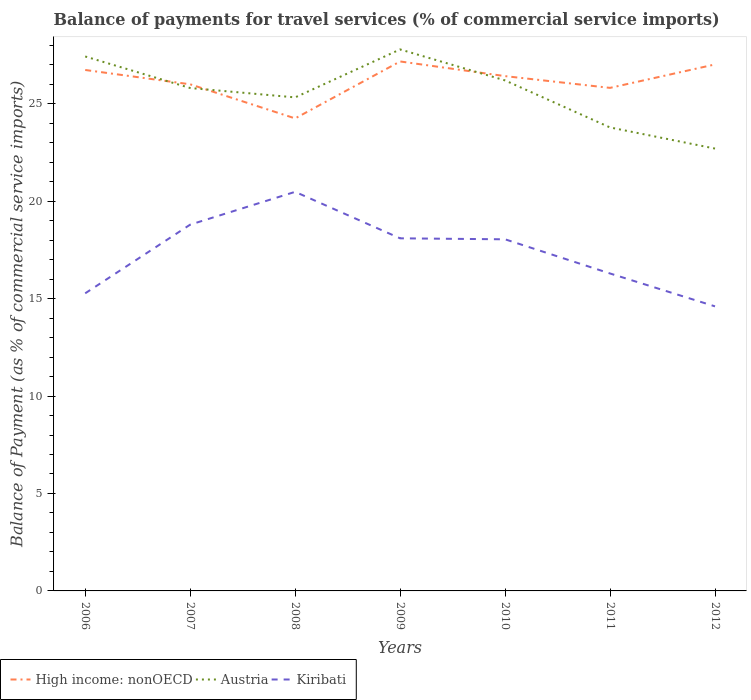Does the line corresponding to High income: nonOECD intersect with the line corresponding to Austria?
Offer a very short reply. Yes. Across all years, what is the maximum balance of payments for travel services in Kiribati?
Offer a terse response. 14.6. In which year was the balance of payments for travel services in Kiribati maximum?
Keep it short and to the point. 2012. What is the total balance of payments for travel services in High income: nonOECD in the graph?
Give a very brief answer. 0.92. What is the difference between the highest and the second highest balance of payments for travel services in Austria?
Provide a succinct answer. 5.09. Is the balance of payments for travel services in Austria strictly greater than the balance of payments for travel services in High income: nonOECD over the years?
Make the answer very short. No. How many lines are there?
Your answer should be compact. 3. What is the difference between two consecutive major ticks on the Y-axis?
Offer a terse response. 5. Does the graph contain grids?
Provide a short and direct response. No. What is the title of the graph?
Offer a very short reply. Balance of payments for travel services (% of commercial service imports). Does "Mexico" appear as one of the legend labels in the graph?
Your answer should be compact. No. What is the label or title of the Y-axis?
Your answer should be compact. Balance of Payment (as % of commercial service imports). What is the Balance of Payment (as % of commercial service imports) of High income: nonOECD in 2006?
Your response must be concise. 26.73. What is the Balance of Payment (as % of commercial service imports) of Austria in 2006?
Ensure brevity in your answer.  27.42. What is the Balance of Payment (as % of commercial service imports) of Kiribati in 2006?
Make the answer very short. 15.27. What is the Balance of Payment (as % of commercial service imports) of High income: nonOECD in 2007?
Keep it short and to the point. 25.99. What is the Balance of Payment (as % of commercial service imports) of Austria in 2007?
Keep it short and to the point. 25.8. What is the Balance of Payment (as % of commercial service imports) of Kiribati in 2007?
Make the answer very short. 18.79. What is the Balance of Payment (as % of commercial service imports) of High income: nonOECD in 2008?
Your response must be concise. 24.24. What is the Balance of Payment (as % of commercial service imports) in Austria in 2008?
Provide a succinct answer. 25.32. What is the Balance of Payment (as % of commercial service imports) of Kiribati in 2008?
Your answer should be compact. 20.48. What is the Balance of Payment (as % of commercial service imports) in High income: nonOECD in 2009?
Your answer should be compact. 27.17. What is the Balance of Payment (as % of commercial service imports) of Austria in 2009?
Offer a terse response. 27.78. What is the Balance of Payment (as % of commercial service imports) of Kiribati in 2009?
Give a very brief answer. 18.09. What is the Balance of Payment (as % of commercial service imports) of High income: nonOECD in 2010?
Offer a very short reply. 26.41. What is the Balance of Payment (as % of commercial service imports) in Austria in 2010?
Your answer should be very brief. 26.19. What is the Balance of Payment (as % of commercial service imports) of Kiribati in 2010?
Give a very brief answer. 18.04. What is the Balance of Payment (as % of commercial service imports) in High income: nonOECD in 2011?
Your answer should be very brief. 25.81. What is the Balance of Payment (as % of commercial service imports) in Austria in 2011?
Give a very brief answer. 23.78. What is the Balance of Payment (as % of commercial service imports) of Kiribati in 2011?
Make the answer very short. 16.29. What is the Balance of Payment (as % of commercial service imports) of High income: nonOECD in 2012?
Keep it short and to the point. 27.01. What is the Balance of Payment (as % of commercial service imports) of Austria in 2012?
Provide a succinct answer. 22.7. What is the Balance of Payment (as % of commercial service imports) in Kiribati in 2012?
Offer a terse response. 14.6. Across all years, what is the maximum Balance of Payment (as % of commercial service imports) of High income: nonOECD?
Provide a succinct answer. 27.17. Across all years, what is the maximum Balance of Payment (as % of commercial service imports) in Austria?
Keep it short and to the point. 27.78. Across all years, what is the maximum Balance of Payment (as % of commercial service imports) in Kiribati?
Offer a terse response. 20.48. Across all years, what is the minimum Balance of Payment (as % of commercial service imports) in High income: nonOECD?
Provide a succinct answer. 24.24. Across all years, what is the minimum Balance of Payment (as % of commercial service imports) of Austria?
Provide a short and direct response. 22.7. Across all years, what is the minimum Balance of Payment (as % of commercial service imports) of Kiribati?
Your response must be concise. 14.6. What is the total Balance of Payment (as % of commercial service imports) in High income: nonOECD in the graph?
Your answer should be very brief. 183.37. What is the total Balance of Payment (as % of commercial service imports) in Austria in the graph?
Offer a terse response. 179. What is the total Balance of Payment (as % of commercial service imports) of Kiribati in the graph?
Keep it short and to the point. 121.56. What is the difference between the Balance of Payment (as % of commercial service imports) in High income: nonOECD in 2006 and that in 2007?
Make the answer very short. 0.74. What is the difference between the Balance of Payment (as % of commercial service imports) in Austria in 2006 and that in 2007?
Provide a succinct answer. 1.62. What is the difference between the Balance of Payment (as % of commercial service imports) in Kiribati in 2006 and that in 2007?
Provide a succinct answer. -3.52. What is the difference between the Balance of Payment (as % of commercial service imports) of High income: nonOECD in 2006 and that in 2008?
Ensure brevity in your answer.  2.48. What is the difference between the Balance of Payment (as % of commercial service imports) of Austria in 2006 and that in 2008?
Give a very brief answer. 2.1. What is the difference between the Balance of Payment (as % of commercial service imports) in Kiribati in 2006 and that in 2008?
Make the answer very short. -5.21. What is the difference between the Balance of Payment (as % of commercial service imports) in High income: nonOECD in 2006 and that in 2009?
Make the answer very short. -0.44. What is the difference between the Balance of Payment (as % of commercial service imports) of Austria in 2006 and that in 2009?
Offer a terse response. -0.36. What is the difference between the Balance of Payment (as % of commercial service imports) of Kiribati in 2006 and that in 2009?
Your response must be concise. -2.82. What is the difference between the Balance of Payment (as % of commercial service imports) in High income: nonOECD in 2006 and that in 2010?
Ensure brevity in your answer.  0.32. What is the difference between the Balance of Payment (as % of commercial service imports) of Austria in 2006 and that in 2010?
Offer a terse response. 1.23. What is the difference between the Balance of Payment (as % of commercial service imports) of Kiribati in 2006 and that in 2010?
Make the answer very short. -2.77. What is the difference between the Balance of Payment (as % of commercial service imports) of High income: nonOECD in 2006 and that in 2011?
Ensure brevity in your answer.  0.92. What is the difference between the Balance of Payment (as % of commercial service imports) in Austria in 2006 and that in 2011?
Provide a succinct answer. 3.64. What is the difference between the Balance of Payment (as % of commercial service imports) in Kiribati in 2006 and that in 2011?
Ensure brevity in your answer.  -1.02. What is the difference between the Balance of Payment (as % of commercial service imports) of High income: nonOECD in 2006 and that in 2012?
Offer a terse response. -0.28. What is the difference between the Balance of Payment (as % of commercial service imports) in Austria in 2006 and that in 2012?
Keep it short and to the point. 4.73. What is the difference between the Balance of Payment (as % of commercial service imports) of Kiribati in 2006 and that in 2012?
Offer a terse response. 0.67. What is the difference between the Balance of Payment (as % of commercial service imports) in High income: nonOECD in 2007 and that in 2008?
Provide a short and direct response. 1.75. What is the difference between the Balance of Payment (as % of commercial service imports) in Austria in 2007 and that in 2008?
Ensure brevity in your answer.  0.48. What is the difference between the Balance of Payment (as % of commercial service imports) of Kiribati in 2007 and that in 2008?
Ensure brevity in your answer.  -1.68. What is the difference between the Balance of Payment (as % of commercial service imports) in High income: nonOECD in 2007 and that in 2009?
Ensure brevity in your answer.  -1.17. What is the difference between the Balance of Payment (as % of commercial service imports) of Austria in 2007 and that in 2009?
Your response must be concise. -1.98. What is the difference between the Balance of Payment (as % of commercial service imports) of Kiribati in 2007 and that in 2009?
Provide a short and direct response. 0.7. What is the difference between the Balance of Payment (as % of commercial service imports) of High income: nonOECD in 2007 and that in 2010?
Your answer should be very brief. -0.42. What is the difference between the Balance of Payment (as % of commercial service imports) of Austria in 2007 and that in 2010?
Offer a very short reply. -0.39. What is the difference between the Balance of Payment (as % of commercial service imports) of Kiribati in 2007 and that in 2010?
Your answer should be compact. 0.75. What is the difference between the Balance of Payment (as % of commercial service imports) of High income: nonOECD in 2007 and that in 2011?
Ensure brevity in your answer.  0.18. What is the difference between the Balance of Payment (as % of commercial service imports) in Austria in 2007 and that in 2011?
Your response must be concise. 2.02. What is the difference between the Balance of Payment (as % of commercial service imports) of Kiribati in 2007 and that in 2011?
Provide a short and direct response. 2.51. What is the difference between the Balance of Payment (as % of commercial service imports) of High income: nonOECD in 2007 and that in 2012?
Provide a short and direct response. -1.02. What is the difference between the Balance of Payment (as % of commercial service imports) in Austria in 2007 and that in 2012?
Make the answer very short. 3.11. What is the difference between the Balance of Payment (as % of commercial service imports) of Kiribati in 2007 and that in 2012?
Keep it short and to the point. 4.19. What is the difference between the Balance of Payment (as % of commercial service imports) in High income: nonOECD in 2008 and that in 2009?
Offer a terse response. -2.92. What is the difference between the Balance of Payment (as % of commercial service imports) in Austria in 2008 and that in 2009?
Provide a short and direct response. -2.46. What is the difference between the Balance of Payment (as % of commercial service imports) of Kiribati in 2008 and that in 2009?
Your answer should be very brief. 2.38. What is the difference between the Balance of Payment (as % of commercial service imports) in High income: nonOECD in 2008 and that in 2010?
Your answer should be compact. -2.17. What is the difference between the Balance of Payment (as % of commercial service imports) in Austria in 2008 and that in 2010?
Keep it short and to the point. -0.87. What is the difference between the Balance of Payment (as % of commercial service imports) of Kiribati in 2008 and that in 2010?
Your answer should be very brief. 2.44. What is the difference between the Balance of Payment (as % of commercial service imports) in High income: nonOECD in 2008 and that in 2011?
Your response must be concise. -1.57. What is the difference between the Balance of Payment (as % of commercial service imports) of Austria in 2008 and that in 2011?
Offer a very short reply. 1.54. What is the difference between the Balance of Payment (as % of commercial service imports) of Kiribati in 2008 and that in 2011?
Offer a very short reply. 4.19. What is the difference between the Balance of Payment (as % of commercial service imports) in High income: nonOECD in 2008 and that in 2012?
Your answer should be compact. -2.77. What is the difference between the Balance of Payment (as % of commercial service imports) of Austria in 2008 and that in 2012?
Your answer should be compact. 2.63. What is the difference between the Balance of Payment (as % of commercial service imports) of Kiribati in 2008 and that in 2012?
Offer a terse response. 5.88. What is the difference between the Balance of Payment (as % of commercial service imports) in High income: nonOECD in 2009 and that in 2010?
Your response must be concise. 0.75. What is the difference between the Balance of Payment (as % of commercial service imports) of Austria in 2009 and that in 2010?
Your answer should be compact. 1.59. What is the difference between the Balance of Payment (as % of commercial service imports) in Kiribati in 2009 and that in 2010?
Ensure brevity in your answer.  0.05. What is the difference between the Balance of Payment (as % of commercial service imports) in High income: nonOECD in 2009 and that in 2011?
Your answer should be compact. 1.36. What is the difference between the Balance of Payment (as % of commercial service imports) of Austria in 2009 and that in 2011?
Keep it short and to the point. 4. What is the difference between the Balance of Payment (as % of commercial service imports) in Kiribati in 2009 and that in 2011?
Make the answer very short. 1.8. What is the difference between the Balance of Payment (as % of commercial service imports) in High income: nonOECD in 2009 and that in 2012?
Offer a terse response. 0.15. What is the difference between the Balance of Payment (as % of commercial service imports) in Austria in 2009 and that in 2012?
Provide a succinct answer. 5.09. What is the difference between the Balance of Payment (as % of commercial service imports) of Kiribati in 2009 and that in 2012?
Your answer should be very brief. 3.49. What is the difference between the Balance of Payment (as % of commercial service imports) of High income: nonOECD in 2010 and that in 2011?
Ensure brevity in your answer.  0.6. What is the difference between the Balance of Payment (as % of commercial service imports) in Austria in 2010 and that in 2011?
Offer a terse response. 2.41. What is the difference between the Balance of Payment (as % of commercial service imports) in Kiribati in 2010 and that in 2011?
Offer a terse response. 1.75. What is the difference between the Balance of Payment (as % of commercial service imports) of High income: nonOECD in 2010 and that in 2012?
Make the answer very short. -0.6. What is the difference between the Balance of Payment (as % of commercial service imports) in Austria in 2010 and that in 2012?
Give a very brief answer. 3.5. What is the difference between the Balance of Payment (as % of commercial service imports) in Kiribati in 2010 and that in 2012?
Ensure brevity in your answer.  3.44. What is the difference between the Balance of Payment (as % of commercial service imports) of High income: nonOECD in 2011 and that in 2012?
Keep it short and to the point. -1.2. What is the difference between the Balance of Payment (as % of commercial service imports) of Austria in 2011 and that in 2012?
Ensure brevity in your answer.  1.08. What is the difference between the Balance of Payment (as % of commercial service imports) in Kiribati in 2011 and that in 2012?
Keep it short and to the point. 1.69. What is the difference between the Balance of Payment (as % of commercial service imports) in High income: nonOECD in 2006 and the Balance of Payment (as % of commercial service imports) in Austria in 2007?
Your response must be concise. 0.93. What is the difference between the Balance of Payment (as % of commercial service imports) of High income: nonOECD in 2006 and the Balance of Payment (as % of commercial service imports) of Kiribati in 2007?
Make the answer very short. 7.94. What is the difference between the Balance of Payment (as % of commercial service imports) in Austria in 2006 and the Balance of Payment (as % of commercial service imports) in Kiribati in 2007?
Make the answer very short. 8.63. What is the difference between the Balance of Payment (as % of commercial service imports) in High income: nonOECD in 2006 and the Balance of Payment (as % of commercial service imports) in Austria in 2008?
Offer a terse response. 1.41. What is the difference between the Balance of Payment (as % of commercial service imports) of High income: nonOECD in 2006 and the Balance of Payment (as % of commercial service imports) of Kiribati in 2008?
Offer a terse response. 6.25. What is the difference between the Balance of Payment (as % of commercial service imports) of Austria in 2006 and the Balance of Payment (as % of commercial service imports) of Kiribati in 2008?
Ensure brevity in your answer.  6.95. What is the difference between the Balance of Payment (as % of commercial service imports) of High income: nonOECD in 2006 and the Balance of Payment (as % of commercial service imports) of Austria in 2009?
Provide a short and direct response. -1.05. What is the difference between the Balance of Payment (as % of commercial service imports) of High income: nonOECD in 2006 and the Balance of Payment (as % of commercial service imports) of Kiribati in 2009?
Your answer should be very brief. 8.64. What is the difference between the Balance of Payment (as % of commercial service imports) in Austria in 2006 and the Balance of Payment (as % of commercial service imports) in Kiribati in 2009?
Make the answer very short. 9.33. What is the difference between the Balance of Payment (as % of commercial service imports) in High income: nonOECD in 2006 and the Balance of Payment (as % of commercial service imports) in Austria in 2010?
Ensure brevity in your answer.  0.54. What is the difference between the Balance of Payment (as % of commercial service imports) in High income: nonOECD in 2006 and the Balance of Payment (as % of commercial service imports) in Kiribati in 2010?
Provide a succinct answer. 8.69. What is the difference between the Balance of Payment (as % of commercial service imports) in Austria in 2006 and the Balance of Payment (as % of commercial service imports) in Kiribati in 2010?
Offer a terse response. 9.38. What is the difference between the Balance of Payment (as % of commercial service imports) in High income: nonOECD in 2006 and the Balance of Payment (as % of commercial service imports) in Austria in 2011?
Make the answer very short. 2.95. What is the difference between the Balance of Payment (as % of commercial service imports) in High income: nonOECD in 2006 and the Balance of Payment (as % of commercial service imports) in Kiribati in 2011?
Provide a succinct answer. 10.44. What is the difference between the Balance of Payment (as % of commercial service imports) of Austria in 2006 and the Balance of Payment (as % of commercial service imports) of Kiribati in 2011?
Ensure brevity in your answer.  11.13. What is the difference between the Balance of Payment (as % of commercial service imports) in High income: nonOECD in 2006 and the Balance of Payment (as % of commercial service imports) in Austria in 2012?
Give a very brief answer. 4.03. What is the difference between the Balance of Payment (as % of commercial service imports) of High income: nonOECD in 2006 and the Balance of Payment (as % of commercial service imports) of Kiribati in 2012?
Offer a very short reply. 12.13. What is the difference between the Balance of Payment (as % of commercial service imports) of Austria in 2006 and the Balance of Payment (as % of commercial service imports) of Kiribati in 2012?
Ensure brevity in your answer.  12.82. What is the difference between the Balance of Payment (as % of commercial service imports) in High income: nonOECD in 2007 and the Balance of Payment (as % of commercial service imports) in Austria in 2008?
Offer a very short reply. 0.67. What is the difference between the Balance of Payment (as % of commercial service imports) of High income: nonOECD in 2007 and the Balance of Payment (as % of commercial service imports) of Kiribati in 2008?
Offer a very short reply. 5.52. What is the difference between the Balance of Payment (as % of commercial service imports) of Austria in 2007 and the Balance of Payment (as % of commercial service imports) of Kiribati in 2008?
Give a very brief answer. 5.33. What is the difference between the Balance of Payment (as % of commercial service imports) in High income: nonOECD in 2007 and the Balance of Payment (as % of commercial service imports) in Austria in 2009?
Your answer should be compact. -1.79. What is the difference between the Balance of Payment (as % of commercial service imports) in High income: nonOECD in 2007 and the Balance of Payment (as % of commercial service imports) in Kiribati in 2009?
Provide a short and direct response. 7.9. What is the difference between the Balance of Payment (as % of commercial service imports) in Austria in 2007 and the Balance of Payment (as % of commercial service imports) in Kiribati in 2009?
Provide a short and direct response. 7.71. What is the difference between the Balance of Payment (as % of commercial service imports) in High income: nonOECD in 2007 and the Balance of Payment (as % of commercial service imports) in Austria in 2010?
Make the answer very short. -0.2. What is the difference between the Balance of Payment (as % of commercial service imports) of High income: nonOECD in 2007 and the Balance of Payment (as % of commercial service imports) of Kiribati in 2010?
Keep it short and to the point. 7.95. What is the difference between the Balance of Payment (as % of commercial service imports) of Austria in 2007 and the Balance of Payment (as % of commercial service imports) of Kiribati in 2010?
Ensure brevity in your answer.  7.76. What is the difference between the Balance of Payment (as % of commercial service imports) of High income: nonOECD in 2007 and the Balance of Payment (as % of commercial service imports) of Austria in 2011?
Give a very brief answer. 2.21. What is the difference between the Balance of Payment (as % of commercial service imports) in High income: nonOECD in 2007 and the Balance of Payment (as % of commercial service imports) in Kiribati in 2011?
Your response must be concise. 9.71. What is the difference between the Balance of Payment (as % of commercial service imports) in Austria in 2007 and the Balance of Payment (as % of commercial service imports) in Kiribati in 2011?
Ensure brevity in your answer.  9.52. What is the difference between the Balance of Payment (as % of commercial service imports) of High income: nonOECD in 2007 and the Balance of Payment (as % of commercial service imports) of Austria in 2012?
Offer a very short reply. 3.3. What is the difference between the Balance of Payment (as % of commercial service imports) of High income: nonOECD in 2007 and the Balance of Payment (as % of commercial service imports) of Kiribati in 2012?
Ensure brevity in your answer.  11.39. What is the difference between the Balance of Payment (as % of commercial service imports) in Austria in 2007 and the Balance of Payment (as % of commercial service imports) in Kiribati in 2012?
Provide a short and direct response. 11.2. What is the difference between the Balance of Payment (as % of commercial service imports) of High income: nonOECD in 2008 and the Balance of Payment (as % of commercial service imports) of Austria in 2009?
Your response must be concise. -3.54. What is the difference between the Balance of Payment (as % of commercial service imports) of High income: nonOECD in 2008 and the Balance of Payment (as % of commercial service imports) of Kiribati in 2009?
Your answer should be very brief. 6.15. What is the difference between the Balance of Payment (as % of commercial service imports) in Austria in 2008 and the Balance of Payment (as % of commercial service imports) in Kiribati in 2009?
Make the answer very short. 7.23. What is the difference between the Balance of Payment (as % of commercial service imports) in High income: nonOECD in 2008 and the Balance of Payment (as % of commercial service imports) in Austria in 2010?
Provide a succinct answer. -1.95. What is the difference between the Balance of Payment (as % of commercial service imports) of High income: nonOECD in 2008 and the Balance of Payment (as % of commercial service imports) of Kiribati in 2010?
Give a very brief answer. 6.2. What is the difference between the Balance of Payment (as % of commercial service imports) in Austria in 2008 and the Balance of Payment (as % of commercial service imports) in Kiribati in 2010?
Your answer should be compact. 7.28. What is the difference between the Balance of Payment (as % of commercial service imports) of High income: nonOECD in 2008 and the Balance of Payment (as % of commercial service imports) of Austria in 2011?
Your answer should be very brief. 0.46. What is the difference between the Balance of Payment (as % of commercial service imports) of High income: nonOECD in 2008 and the Balance of Payment (as % of commercial service imports) of Kiribati in 2011?
Your answer should be compact. 7.96. What is the difference between the Balance of Payment (as % of commercial service imports) in Austria in 2008 and the Balance of Payment (as % of commercial service imports) in Kiribati in 2011?
Ensure brevity in your answer.  9.04. What is the difference between the Balance of Payment (as % of commercial service imports) in High income: nonOECD in 2008 and the Balance of Payment (as % of commercial service imports) in Austria in 2012?
Offer a very short reply. 1.55. What is the difference between the Balance of Payment (as % of commercial service imports) in High income: nonOECD in 2008 and the Balance of Payment (as % of commercial service imports) in Kiribati in 2012?
Offer a terse response. 9.64. What is the difference between the Balance of Payment (as % of commercial service imports) of Austria in 2008 and the Balance of Payment (as % of commercial service imports) of Kiribati in 2012?
Your answer should be very brief. 10.72. What is the difference between the Balance of Payment (as % of commercial service imports) in High income: nonOECD in 2009 and the Balance of Payment (as % of commercial service imports) in Austria in 2010?
Give a very brief answer. 0.97. What is the difference between the Balance of Payment (as % of commercial service imports) in High income: nonOECD in 2009 and the Balance of Payment (as % of commercial service imports) in Kiribati in 2010?
Give a very brief answer. 9.13. What is the difference between the Balance of Payment (as % of commercial service imports) of Austria in 2009 and the Balance of Payment (as % of commercial service imports) of Kiribati in 2010?
Offer a terse response. 9.74. What is the difference between the Balance of Payment (as % of commercial service imports) in High income: nonOECD in 2009 and the Balance of Payment (as % of commercial service imports) in Austria in 2011?
Ensure brevity in your answer.  3.39. What is the difference between the Balance of Payment (as % of commercial service imports) in High income: nonOECD in 2009 and the Balance of Payment (as % of commercial service imports) in Kiribati in 2011?
Provide a short and direct response. 10.88. What is the difference between the Balance of Payment (as % of commercial service imports) in Austria in 2009 and the Balance of Payment (as % of commercial service imports) in Kiribati in 2011?
Provide a succinct answer. 11.5. What is the difference between the Balance of Payment (as % of commercial service imports) in High income: nonOECD in 2009 and the Balance of Payment (as % of commercial service imports) in Austria in 2012?
Make the answer very short. 4.47. What is the difference between the Balance of Payment (as % of commercial service imports) in High income: nonOECD in 2009 and the Balance of Payment (as % of commercial service imports) in Kiribati in 2012?
Offer a very short reply. 12.57. What is the difference between the Balance of Payment (as % of commercial service imports) of Austria in 2009 and the Balance of Payment (as % of commercial service imports) of Kiribati in 2012?
Your answer should be compact. 13.18. What is the difference between the Balance of Payment (as % of commercial service imports) in High income: nonOECD in 2010 and the Balance of Payment (as % of commercial service imports) in Austria in 2011?
Your answer should be compact. 2.63. What is the difference between the Balance of Payment (as % of commercial service imports) of High income: nonOECD in 2010 and the Balance of Payment (as % of commercial service imports) of Kiribati in 2011?
Your response must be concise. 10.13. What is the difference between the Balance of Payment (as % of commercial service imports) in Austria in 2010 and the Balance of Payment (as % of commercial service imports) in Kiribati in 2011?
Provide a succinct answer. 9.91. What is the difference between the Balance of Payment (as % of commercial service imports) of High income: nonOECD in 2010 and the Balance of Payment (as % of commercial service imports) of Austria in 2012?
Ensure brevity in your answer.  3.72. What is the difference between the Balance of Payment (as % of commercial service imports) of High income: nonOECD in 2010 and the Balance of Payment (as % of commercial service imports) of Kiribati in 2012?
Offer a very short reply. 11.81. What is the difference between the Balance of Payment (as % of commercial service imports) in Austria in 2010 and the Balance of Payment (as % of commercial service imports) in Kiribati in 2012?
Ensure brevity in your answer.  11.59. What is the difference between the Balance of Payment (as % of commercial service imports) in High income: nonOECD in 2011 and the Balance of Payment (as % of commercial service imports) in Austria in 2012?
Give a very brief answer. 3.11. What is the difference between the Balance of Payment (as % of commercial service imports) in High income: nonOECD in 2011 and the Balance of Payment (as % of commercial service imports) in Kiribati in 2012?
Offer a terse response. 11.21. What is the difference between the Balance of Payment (as % of commercial service imports) in Austria in 2011 and the Balance of Payment (as % of commercial service imports) in Kiribati in 2012?
Your answer should be very brief. 9.18. What is the average Balance of Payment (as % of commercial service imports) in High income: nonOECD per year?
Make the answer very short. 26.2. What is the average Balance of Payment (as % of commercial service imports) of Austria per year?
Offer a terse response. 25.57. What is the average Balance of Payment (as % of commercial service imports) in Kiribati per year?
Your response must be concise. 17.37. In the year 2006, what is the difference between the Balance of Payment (as % of commercial service imports) in High income: nonOECD and Balance of Payment (as % of commercial service imports) in Austria?
Give a very brief answer. -0.69. In the year 2006, what is the difference between the Balance of Payment (as % of commercial service imports) in High income: nonOECD and Balance of Payment (as % of commercial service imports) in Kiribati?
Give a very brief answer. 11.46. In the year 2006, what is the difference between the Balance of Payment (as % of commercial service imports) of Austria and Balance of Payment (as % of commercial service imports) of Kiribati?
Your answer should be very brief. 12.15. In the year 2007, what is the difference between the Balance of Payment (as % of commercial service imports) of High income: nonOECD and Balance of Payment (as % of commercial service imports) of Austria?
Provide a succinct answer. 0.19. In the year 2007, what is the difference between the Balance of Payment (as % of commercial service imports) of High income: nonOECD and Balance of Payment (as % of commercial service imports) of Kiribati?
Give a very brief answer. 7.2. In the year 2007, what is the difference between the Balance of Payment (as % of commercial service imports) in Austria and Balance of Payment (as % of commercial service imports) in Kiribati?
Ensure brevity in your answer.  7.01. In the year 2008, what is the difference between the Balance of Payment (as % of commercial service imports) in High income: nonOECD and Balance of Payment (as % of commercial service imports) in Austria?
Your answer should be very brief. -1.08. In the year 2008, what is the difference between the Balance of Payment (as % of commercial service imports) of High income: nonOECD and Balance of Payment (as % of commercial service imports) of Kiribati?
Offer a terse response. 3.77. In the year 2008, what is the difference between the Balance of Payment (as % of commercial service imports) of Austria and Balance of Payment (as % of commercial service imports) of Kiribati?
Offer a very short reply. 4.85. In the year 2009, what is the difference between the Balance of Payment (as % of commercial service imports) of High income: nonOECD and Balance of Payment (as % of commercial service imports) of Austria?
Provide a short and direct response. -0.62. In the year 2009, what is the difference between the Balance of Payment (as % of commercial service imports) of High income: nonOECD and Balance of Payment (as % of commercial service imports) of Kiribati?
Offer a terse response. 9.07. In the year 2009, what is the difference between the Balance of Payment (as % of commercial service imports) of Austria and Balance of Payment (as % of commercial service imports) of Kiribati?
Your answer should be very brief. 9.69. In the year 2010, what is the difference between the Balance of Payment (as % of commercial service imports) in High income: nonOECD and Balance of Payment (as % of commercial service imports) in Austria?
Make the answer very short. 0.22. In the year 2010, what is the difference between the Balance of Payment (as % of commercial service imports) in High income: nonOECD and Balance of Payment (as % of commercial service imports) in Kiribati?
Offer a very short reply. 8.37. In the year 2010, what is the difference between the Balance of Payment (as % of commercial service imports) in Austria and Balance of Payment (as % of commercial service imports) in Kiribati?
Keep it short and to the point. 8.15. In the year 2011, what is the difference between the Balance of Payment (as % of commercial service imports) in High income: nonOECD and Balance of Payment (as % of commercial service imports) in Austria?
Your response must be concise. 2.03. In the year 2011, what is the difference between the Balance of Payment (as % of commercial service imports) in High income: nonOECD and Balance of Payment (as % of commercial service imports) in Kiribati?
Give a very brief answer. 9.52. In the year 2011, what is the difference between the Balance of Payment (as % of commercial service imports) of Austria and Balance of Payment (as % of commercial service imports) of Kiribati?
Your response must be concise. 7.49. In the year 2012, what is the difference between the Balance of Payment (as % of commercial service imports) of High income: nonOECD and Balance of Payment (as % of commercial service imports) of Austria?
Offer a very short reply. 4.32. In the year 2012, what is the difference between the Balance of Payment (as % of commercial service imports) in High income: nonOECD and Balance of Payment (as % of commercial service imports) in Kiribati?
Provide a succinct answer. 12.41. In the year 2012, what is the difference between the Balance of Payment (as % of commercial service imports) of Austria and Balance of Payment (as % of commercial service imports) of Kiribati?
Provide a short and direct response. 8.1. What is the ratio of the Balance of Payment (as % of commercial service imports) of High income: nonOECD in 2006 to that in 2007?
Give a very brief answer. 1.03. What is the ratio of the Balance of Payment (as % of commercial service imports) in Austria in 2006 to that in 2007?
Give a very brief answer. 1.06. What is the ratio of the Balance of Payment (as % of commercial service imports) in Kiribati in 2006 to that in 2007?
Your answer should be compact. 0.81. What is the ratio of the Balance of Payment (as % of commercial service imports) in High income: nonOECD in 2006 to that in 2008?
Your response must be concise. 1.1. What is the ratio of the Balance of Payment (as % of commercial service imports) of Austria in 2006 to that in 2008?
Give a very brief answer. 1.08. What is the ratio of the Balance of Payment (as % of commercial service imports) in Kiribati in 2006 to that in 2008?
Offer a very short reply. 0.75. What is the ratio of the Balance of Payment (as % of commercial service imports) of High income: nonOECD in 2006 to that in 2009?
Offer a very short reply. 0.98. What is the ratio of the Balance of Payment (as % of commercial service imports) of Kiribati in 2006 to that in 2009?
Ensure brevity in your answer.  0.84. What is the ratio of the Balance of Payment (as % of commercial service imports) in High income: nonOECD in 2006 to that in 2010?
Give a very brief answer. 1.01. What is the ratio of the Balance of Payment (as % of commercial service imports) in Austria in 2006 to that in 2010?
Provide a short and direct response. 1.05. What is the ratio of the Balance of Payment (as % of commercial service imports) of Kiribati in 2006 to that in 2010?
Your response must be concise. 0.85. What is the ratio of the Balance of Payment (as % of commercial service imports) of High income: nonOECD in 2006 to that in 2011?
Make the answer very short. 1.04. What is the ratio of the Balance of Payment (as % of commercial service imports) of Austria in 2006 to that in 2011?
Your answer should be very brief. 1.15. What is the ratio of the Balance of Payment (as % of commercial service imports) in Kiribati in 2006 to that in 2011?
Make the answer very short. 0.94. What is the ratio of the Balance of Payment (as % of commercial service imports) in Austria in 2006 to that in 2012?
Your answer should be compact. 1.21. What is the ratio of the Balance of Payment (as % of commercial service imports) in Kiribati in 2006 to that in 2012?
Offer a very short reply. 1.05. What is the ratio of the Balance of Payment (as % of commercial service imports) in High income: nonOECD in 2007 to that in 2008?
Keep it short and to the point. 1.07. What is the ratio of the Balance of Payment (as % of commercial service imports) of Austria in 2007 to that in 2008?
Make the answer very short. 1.02. What is the ratio of the Balance of Payment (as % of commercial service imports) of Kiribati in 2007 to that in 2008?
Provide a succinct answer. 0.92. What is the ratio of the Balance of Payment (as % of commercial service imports) of High income: nonOECD in 2007 to that in 2009?
Make the answer very short. 0.96. What is the ratio of the Balance of Payment (as % of commercial service imports) of Austria in 2007 to that in 2009?
Ensure brevity in your answer.  0.93. What is the ratio of the Balance of Payment (as % of commercial service imports) in Kiribati in 2007 to that in 2009?
Make the answer very short. 1.04. What is the ratio of the Balance of Payment (as % of commercial service imports) in High income: nonOECD in 2007 to that in 2010?
Offer a terse response. 0.98. What is the ratio of the Balance of Payment (as % of commercial service imports) of Austria in 2007 to that in 2010?
Your answer should be very brief. 0.99. What is the ratio of the Balance of Payment (as % of commercial service imports) of Kiribati in 2007 to that in 2010?
Provide a succinct answer. 1.04. What is the ratio of the Balance of Payment (as % of commercial service imports) of High income: nonOECD in 2007 to that in 2011?
Keep it short and to the point. 1.01. What is the ratio of the Balance of Payment (as % of commercial service imports) of Austria in 2007 to that in 2011?
Ensure brevity in your answer.  1.09. What is the ratio of the Balance of Payment (as % of commercial service imports) in Kiribati in 2007 to that in 2011?
Make the answer very short. 1.15. What is the ratio of the Balance of Payment (as % of commercial service imports) in High income: nonOECD in 2007 to that in 2012?
Offer a terse response. 0.96. What is the ratio of the Balance of Payment (as % of commercial service imports) of Austria in 2007 to that in 2012?
Your answer should be compact. 1.14. What is the ratio of the Balance of Payment (as % of commercial service imports) of Kiribati in 2007 to that in 2012?
Offer a very short reply. 1.29. What is the ratio of the Balance of Payment (as % of commercial service imports) of High income: nonOECD in 2008 to that in 2009?
Your response must be concise. 0.89. What is the ratio of the Balance of Payment (as % of commercial service imports) in Austria in 2008 to that in 2009?
Provide a short and direct response. 0.91. What is the ratio of the Balance of Payment (as % of commercial service imports) in Kiribati in 2008 to that in 2009?
Provide a short and direct response. 1.13. What is the ratio of the Balance of Payment (as % of commercial service imports) in High income: nonOECD in 2008 to that in 2010?
Ensure brevity in your answer.  0.92. What is the ratio of the Balance of Payment (as % of commercial service imports) in Austria in 2008 to that in 2010?
Keep it short and to the point. 0.97. What is the ratio of the Balance of Payment (as % of commercial service imports) in Kiribati in 2008 to that in 2010?
Keep it short and to the point. 1.14. What is the ratio of the Balance of Payment (as % of commercial service imports) of High income: nonOECD in 2008 to that in 2011?
Your answer should be very brief. 0.94. What is the ratio of the Balance of Payment (as % of commercial service imports) of Austria in 2008 to that in 2011?
Provide a succinct answer. 1.06. What is the ratio of the Balance of Payment (as % of commercial service imports) in Kiribati in 2008 to that in 2011?
Give a very brief answer. 1.26. What is the ratio of the Balance of Payment (as % of commercial service imports) of High income: nonOECD in 2008 to that in 2012?
Your answer should be compact. 0.9. What is the ratio of the Balance of Payment (as % of commercial service imports) in Austria in 2008 to that in 2012?
Ensure brevity in your answer.  1.12. What is the ratio of the Balance of Payment (as % of commercial service imports) in Kiribati in 2008 to that in 2012?
Provide a succinct answer. 1.4. What is the ratio of the Balance of Payment (as % of commercial service imports) of High income: nonOECD in 2009 to that in 2010?
Keep it short and to the point. 1.03. What is the ratio of the Balance of Payment (as % of commercial service imports) in Austria in 2009 to that in 2010?
Provide a short and direct response. 1.06. What is the ratio of the Balance of Payment (as % of commercial service imports) in Kiribati in 2009 to that in 2010?
Your response must be concise. 1. What is the ratio of the Balance of Payment (as % of commercial service imports) of High income: nonOECD in 2009 to that in 2011?
Make the answer very short. 1.05. What is the ratio of the Balance of Payment (as % of commercial service imports) of Austria in 2009 to that in 2011?
Make the answer very short. 1.17. What is the ratio of the Balance of Payment (as % of commercial service imports) in Kiribati in 2009 to that in 2011?
Offer a terse response. 1.11. What is the ratio of the Balance of Payment (as % of commercial service imports) in High income: nonOECD in 2009 to that in 2012?
Provide a succinct answer. 1.01. What is the ratio of the Balance of Payment (as % of commercial service imports) of Austria in 2009 to that in 2012?
Offer a very short reply. 1.22. What is the ratio of the Balance of Payment (as % of commercial service imports) of Kiribati in 2009 to that in 2012?
Keep it short and to the point. 1.24. What is the ratio of the Balance of Payment (as % of commercial service imports) of High income: nonOECD in 2010 to that in 2011?
Your response must be concise. 1.02. What is the ratio of the Balance of Payment (as % of commercial service imports) of Austria in 2010 to that in 2011?
Provide a short and direct response. 1.1. What is the ratio of the Balance of Payment (as % of commercial service imports) in Kiribati in 2010 to that in 2011?
Give a very brief answer. 1.11. What is the ratio of the Balance of Payment (as % of commercial service imports) in High income: nonOECD in 2010 to that in 2012?
Make the answer very short. 0.98. What is the ratio of the Balance of Payment (as % of commercial service imports) of Austria in 2010 to that in 2012?
Make the answer very short. 1.15. What is the ratio of the Balance of Payment (as % of commercial service imports) of Kiribati in 2010 to that in 2012?
Your answer should be compact. 1.24. What is the ratio of the Balance of Payment (as % of commercial service imports) of High income: nonOECD in 2011 to that in 2012?
Give a very brief answer. 0.96. What is the ratio of the Balance of Payment (as % of commercial service imports) in Austria in 2011 to that in 2012?
Give a very brief answer. 1.05. What is the ratio of the Balance of Payment (as % of commercial service imports) in Kiribati in 2011 to that in 2012?
Provide a succinct answer. 1.12. What is the difference between the highest and the second highest Balance of Payment (as % of commercial service imports) in High income: nonOECD?
Offer a very short reply. 0.15. What is the difference between the highest and the second highest Balance of Payment (as % of commercial service imports) of Austria?
Offer a very short reply. 0.36. What is the difference between the highest and the second highest Balance of Payment (as % of commercial service imports) of Kiribati?
Your answer should be compact. 1.68. What is the difference between the highest and the lowest Balance of Payment (as % of commercial service imports) of High income: nonOECD?
Offer a terse response. 2.92. What is the difference between the highest and the lowest Balance of Payment (as % of commercial service imports) in Austria?
Your answer should be compact. 5.09. What is the difference between the highest and the lowest Balance of Payment (as % of commercial service imports) in Kiribati?
Provide a short and direct response. 5.88. 